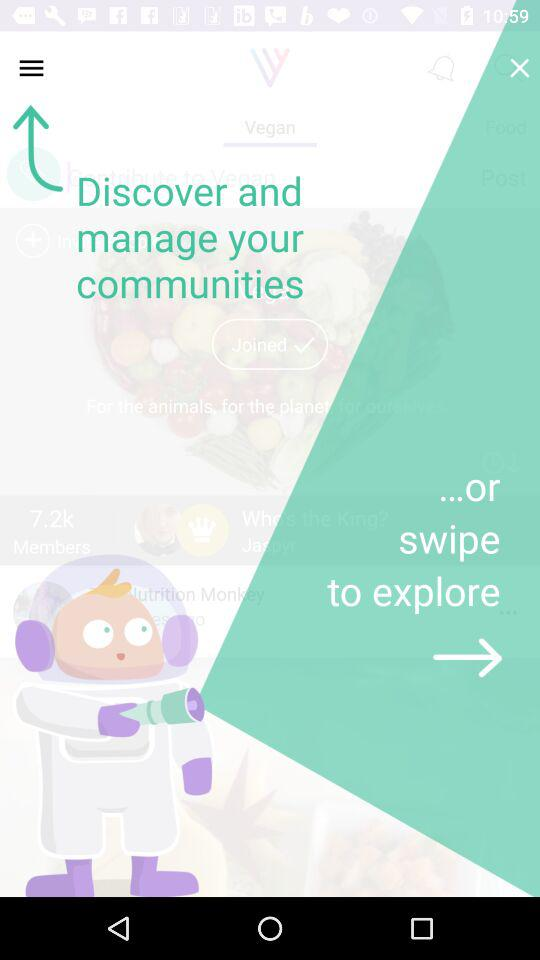Which options are there to log in to the application? The options are "Facebook", "Google+", "Twitter" and "Email". 